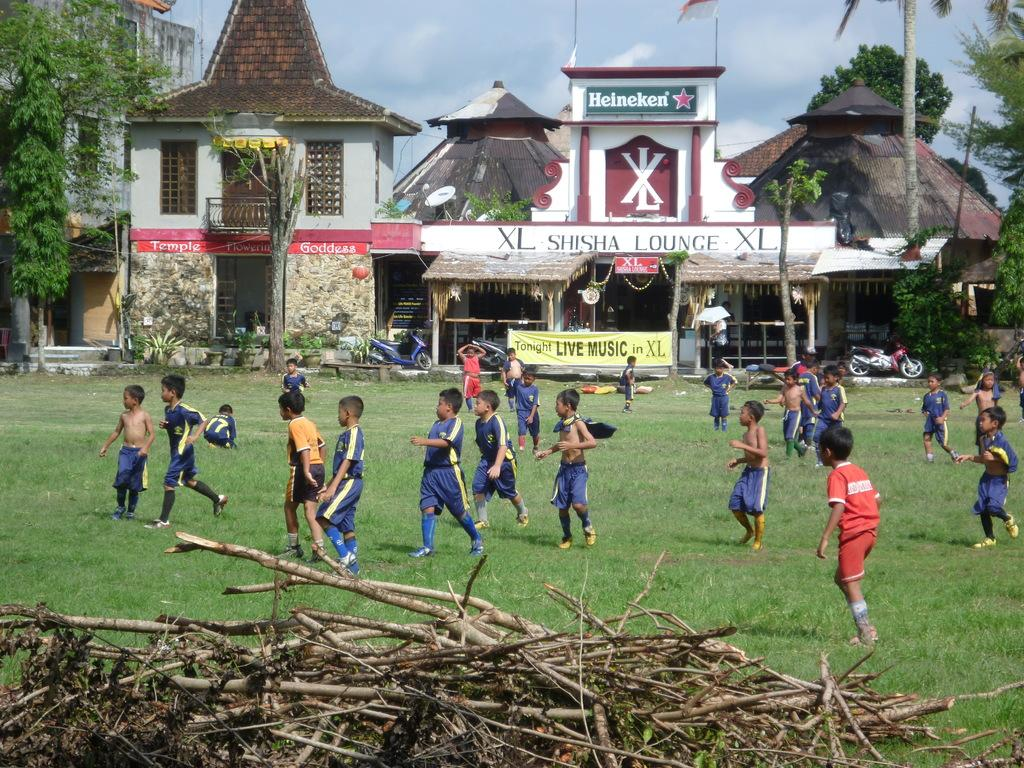How many children are present in the image? There are many children in the image. What are the children doing in the image? The children are playing on the ground. What type of surface are the children playing on? There are grasses on the ground where the children are playing. What type of cake is being served to the girl in the image? There is no cake or girl present in the image; it only shows children playing on grass. 